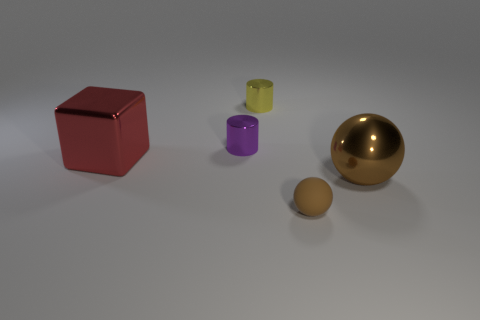Add 2 purple rubber things. How many objects exist? 7 Subtract all spheres. How many objects are left? 3 Subtract all large brown shiny spheres. Subtract all small yellow shiny cylinders. How many objects are left? 3 Add 5 big red metal cubes. How many big red metal cubes are left? 6 Add 4 yellow cylinders. How many yellow cylinders exist? 5 Subtract 0 gray cylinders. How many objects are left? 5 